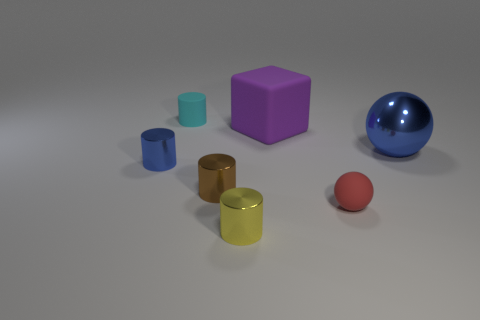Subtract all balls. How many objects are left? 5 Subtract 1 blocks. How many blocks are left? 0 Subtract all brown spheres. Subtract all gray cylinders. How many spheres are left? 2 Subtract all purple blocks. How many blue cylinders are left? 1 Subtract all large cyan metal balls. Subtract all big purple blocks. How many objects are left? 6 Add 7 matte things. How many matte things are left? 10 Add 7 red metallic balls. How many red metallic balls exist? 7 Add 1 big purple matte objects. How many objects exist? 8 Subtract all yellow cylinders. How many cylinders are left? 3 Subtract all tiny metal cylinders. How many cylinders are left? 1 